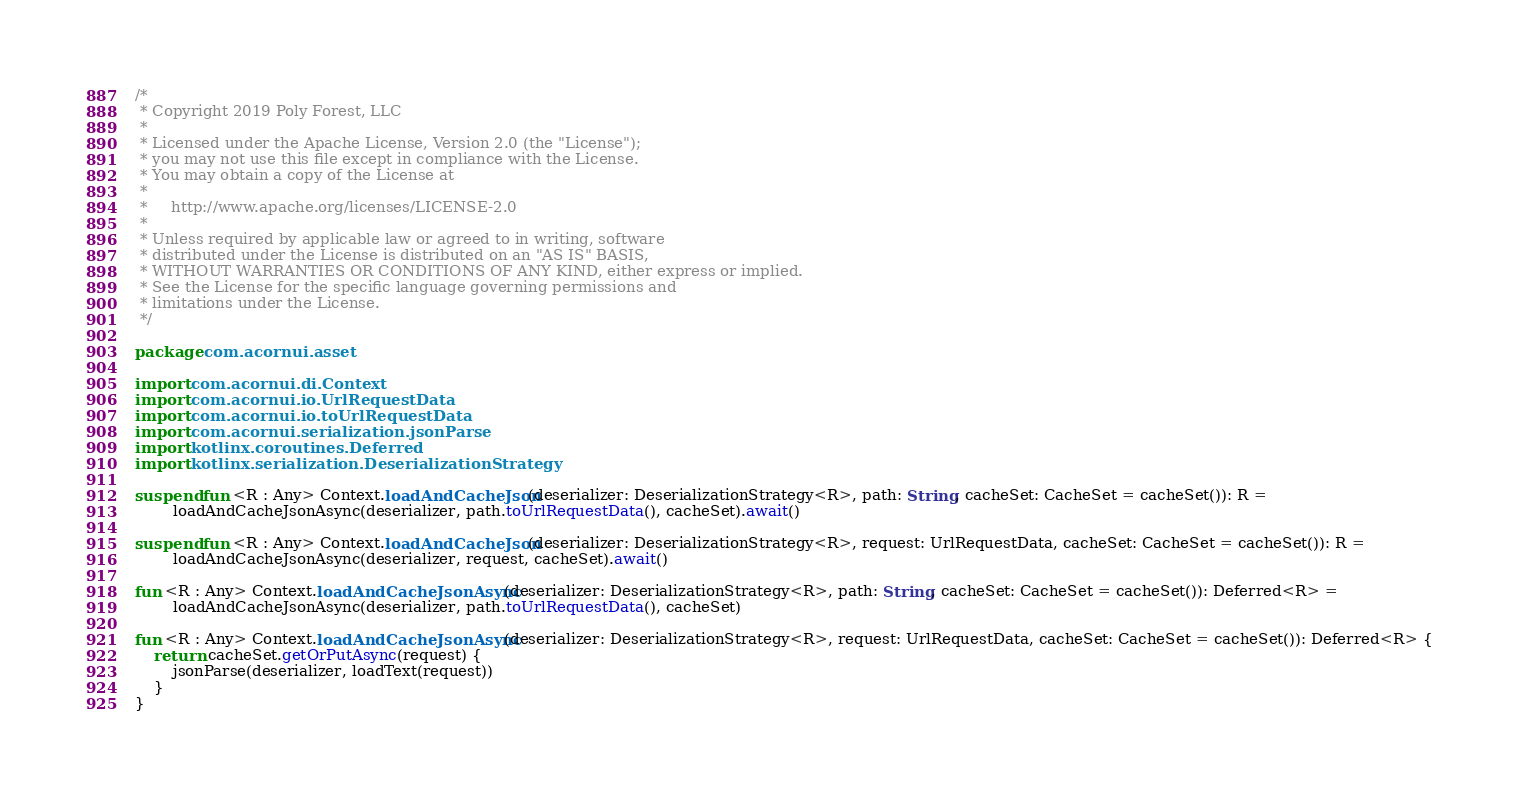Convert code to text. <code><loc_0><loc_0><loc_500><loc_500><_Kotlin_>/*
 * Copyright 2019 Poly Forest, LLC
 *
 * Licensed under the Apache License, Version 2.0 (the "License");
 * you may not use this file except in compliance with the License.
 * You may obtain a copy of the License at
 *
 *     http://www.apache.org/licenses/LICENSE-2.0
 *
 * Unless required by applicable law or agreed to in writing, software
 * distributed under the License is distributed on an "AS IS" BASIS,
 * WITHOUT WARRANTIES OR CONDITIONS OF ANY KIND, either express or implied.
 * See the License for the specific language governing permissions and
 * limitations under the License.
 */

package com.acornui.asset

import com.acornui.di.Context
import com.acornui.io.UrlRequestData
import com.acornui.io.toUrlRequestData
import com.acornui.serialization.jsonParse
import kotlinx.coroutines.Deferred
import kotlinx.serialization.DeserializationStrategy

suspend fun <R : Any> Context.loadAndCacheJson(deserializer: DeserializationStrategy<R>, path: String, cacheSet: CacheSet = cacheSet()): R =
		loadAndCacheJsonAsync(deserializer, path.toUrlRequestData(), cacheSet).await()

suspend fun <R : Any> Context.loadAndCacheJson(deserializer: DeserializationStrategy<R>, request: UrlRequestData, cacheSet: CacheSet = cacheSet()): R =
		loadAndCacheJsonAsync(deserializer, request, cacheSet).await()

fun <R : Any> Context.loadAndCacheJsonAsync(deserializer: DeserializationStrategy<R>, path: String, cacheSet: CacheSet = cacheSet()): Deferred<R> =
		loadAndCacheJsonAsync(deserializer, path.toUrlRequestData(), cacheSet)

fun <R : Any> Context.loadAndCacheJsonAsync(deserializer: DeserializationStrategy<R>, request: UrlRequestData, cacheSet: CacheSet = cacheSet()): Deferred<R> {
	return cacheSet.getOrPutAsync(request) {
		jsonParse(deserializer, loadText(request))
	}
}</code> 